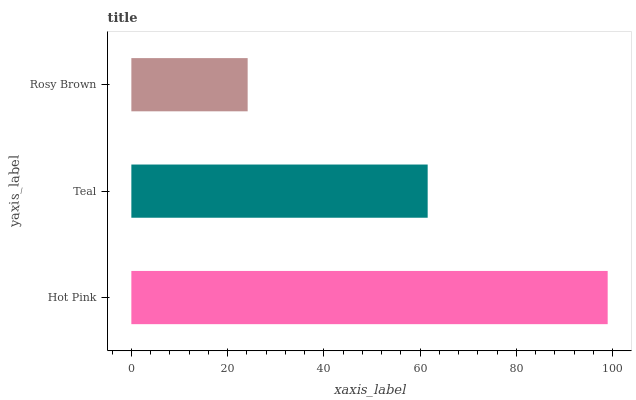Is Rosy Brown the minimum?
Answer yes or no. Yes. Is Hot Pink the maximum?
Answer yes or no. Yes. Is Teal the minimum?
Answer yes or no. No. Is Teal the maximum?
Answer yes or no. No. Is Hot Pink greater than Teal?
Answer yes or no. Yes. Is Teal less than Hot Pink?
Answer yes or no. Yes. Is Teal greater than Hot Pink?
Answer yes or no. No. Is Hot Pink less than Teal?
Answer yes or no. No. Is Teal the high median?
Answer yes or no. Yes. Is Teal the low median?
Answer yes or no. Yes. Is Hot Pink the high median?
Answer yes or no. No. Is Rosy Brown the low median?
Answer yes or no. No. 